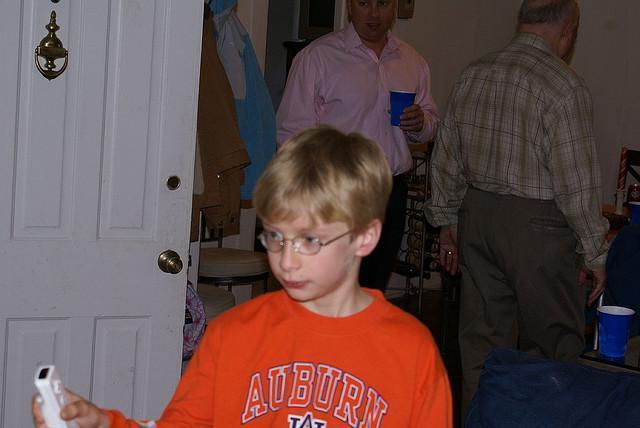How many people are in the photo?
Give a very brief answer. 4. 